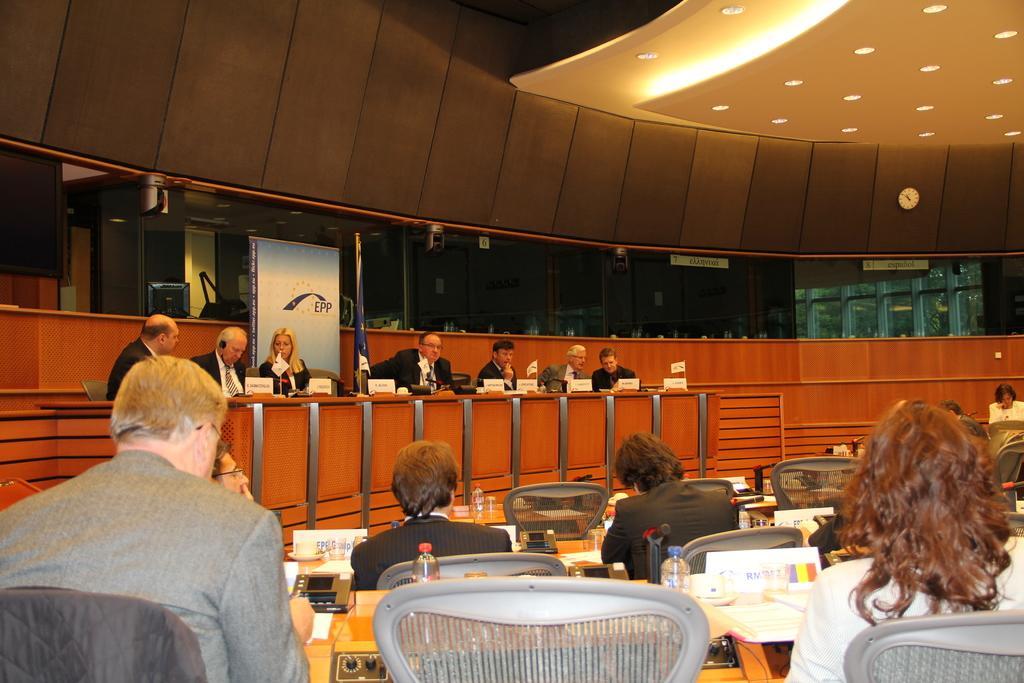Could you give a brief overview of what you see in this image? In this image, we can see people wearing coats and sitting on the chairs and there are name boards, flags, bottles, papers and some other objects on the tables and we can see glass doors, a clock, board, screen, monitor and there are lights. At the top, there is a roof. 